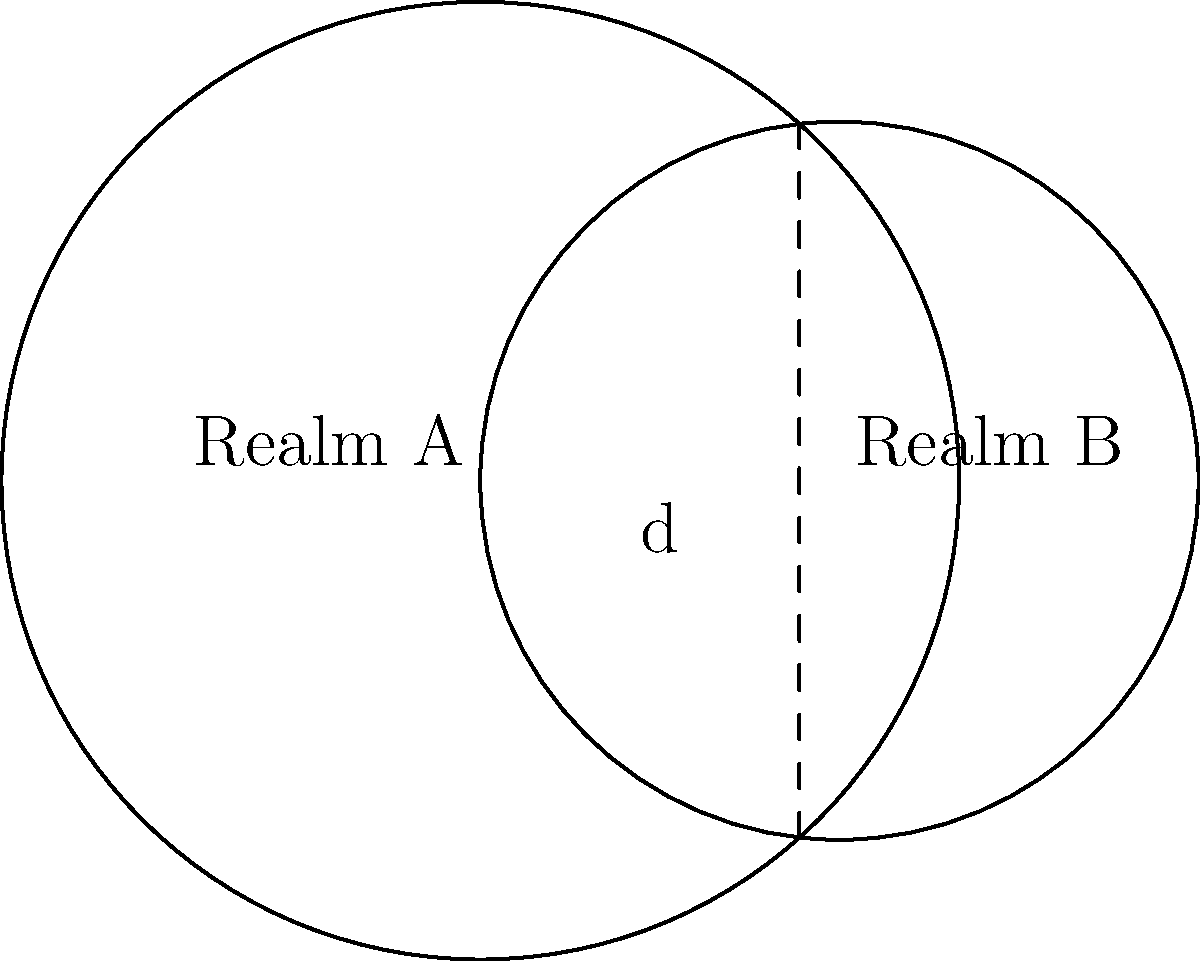In the supernatural world of "Supernatural," two realms, A and B, are represented by overlapping circles. Realm A has a radius of 4 units, while Realm B has a radius of 3 units. The centers of these realms are 3 units apart. Calculate the area of the overlapping region, which represents the intersection of these supernatural realms. Use $\pi = 3.14$ for your calculations. To find the area of overlap between two circles, we'll use the following steps:

1) First, we need to find the central angle $\theta$ for each circle. We can do this using the cosine law:

   $\cos(\frac{\theta_1}{2}) = \frac{d^2 + r_1^2 - r_2^2}{2dr_1}$
   $\cos(\frac{\theta_2}{2}) = \frac{d^2 + r_2^2 - r_1^2}{2dr_2}$

   Where $d$ is the distance between centers, and $r_1$ and $r_2$ are the radii.

2) Plugging in our values:

   $\cos(\frac{\theta_1}{2}) = \frac{3^2 + 4^2 - 3^2}{2(3)(4)} = \frac{16}{24} = \frac{2}{3}$
   $\cos(\frac{\theta_2}{2}) = \frac{3^2 + 3^2 - 4^2}{2(3)(3)} = \frac{2}{6} = \frac{1}{3}$

3) Taking the inverse cosine:

   $\frac{\theta_1}{2} = \arccos(\frac{2}{3}) \approx 0.8411$ radians
   $\frac{\theta_2}{2} = \arccos(\frac{1}{3}) \approx 1.2310$ radians

4) The area of overlap is given by:

   $A = r_1^2 \arccos(\frac{d^2 + r_1^2 - r_2^2}{2dr_1}) + r_2^2 \arccos(\frac{d^2 + r_2^2 - r_1^2}{2dr_2}) - \frac{1}{2}\sqrt{(-d+r_1+r_2)(d+r_1-r_2)(d-r_1+r_2)(d+r_1+r_2)}$

5) Substituting our values:

   $A = 4^2 (2(0.8411)) + 3^2 (2(1.2310)) - \frac{1}{2}\sqrt{(-3+4+3)(3+4-3)(3-4+3)(3+4+3)}$
   $A = 16(1.6822) + 9(2.4620) - \frac{1}{2}\sqrt{4 \cdot 4 \cdot 2 \cdot 10}$
   $A = 26.9152 + 22.1580 - \frac{1}{2}\sqrt{320}$
   $A = 49.0732 - 8.9443$
   $A = 40.1289$ square units

6) Rounding to two decimal places:

   $A \approx 40.13$ square units
Answer: $40.13$ square units 